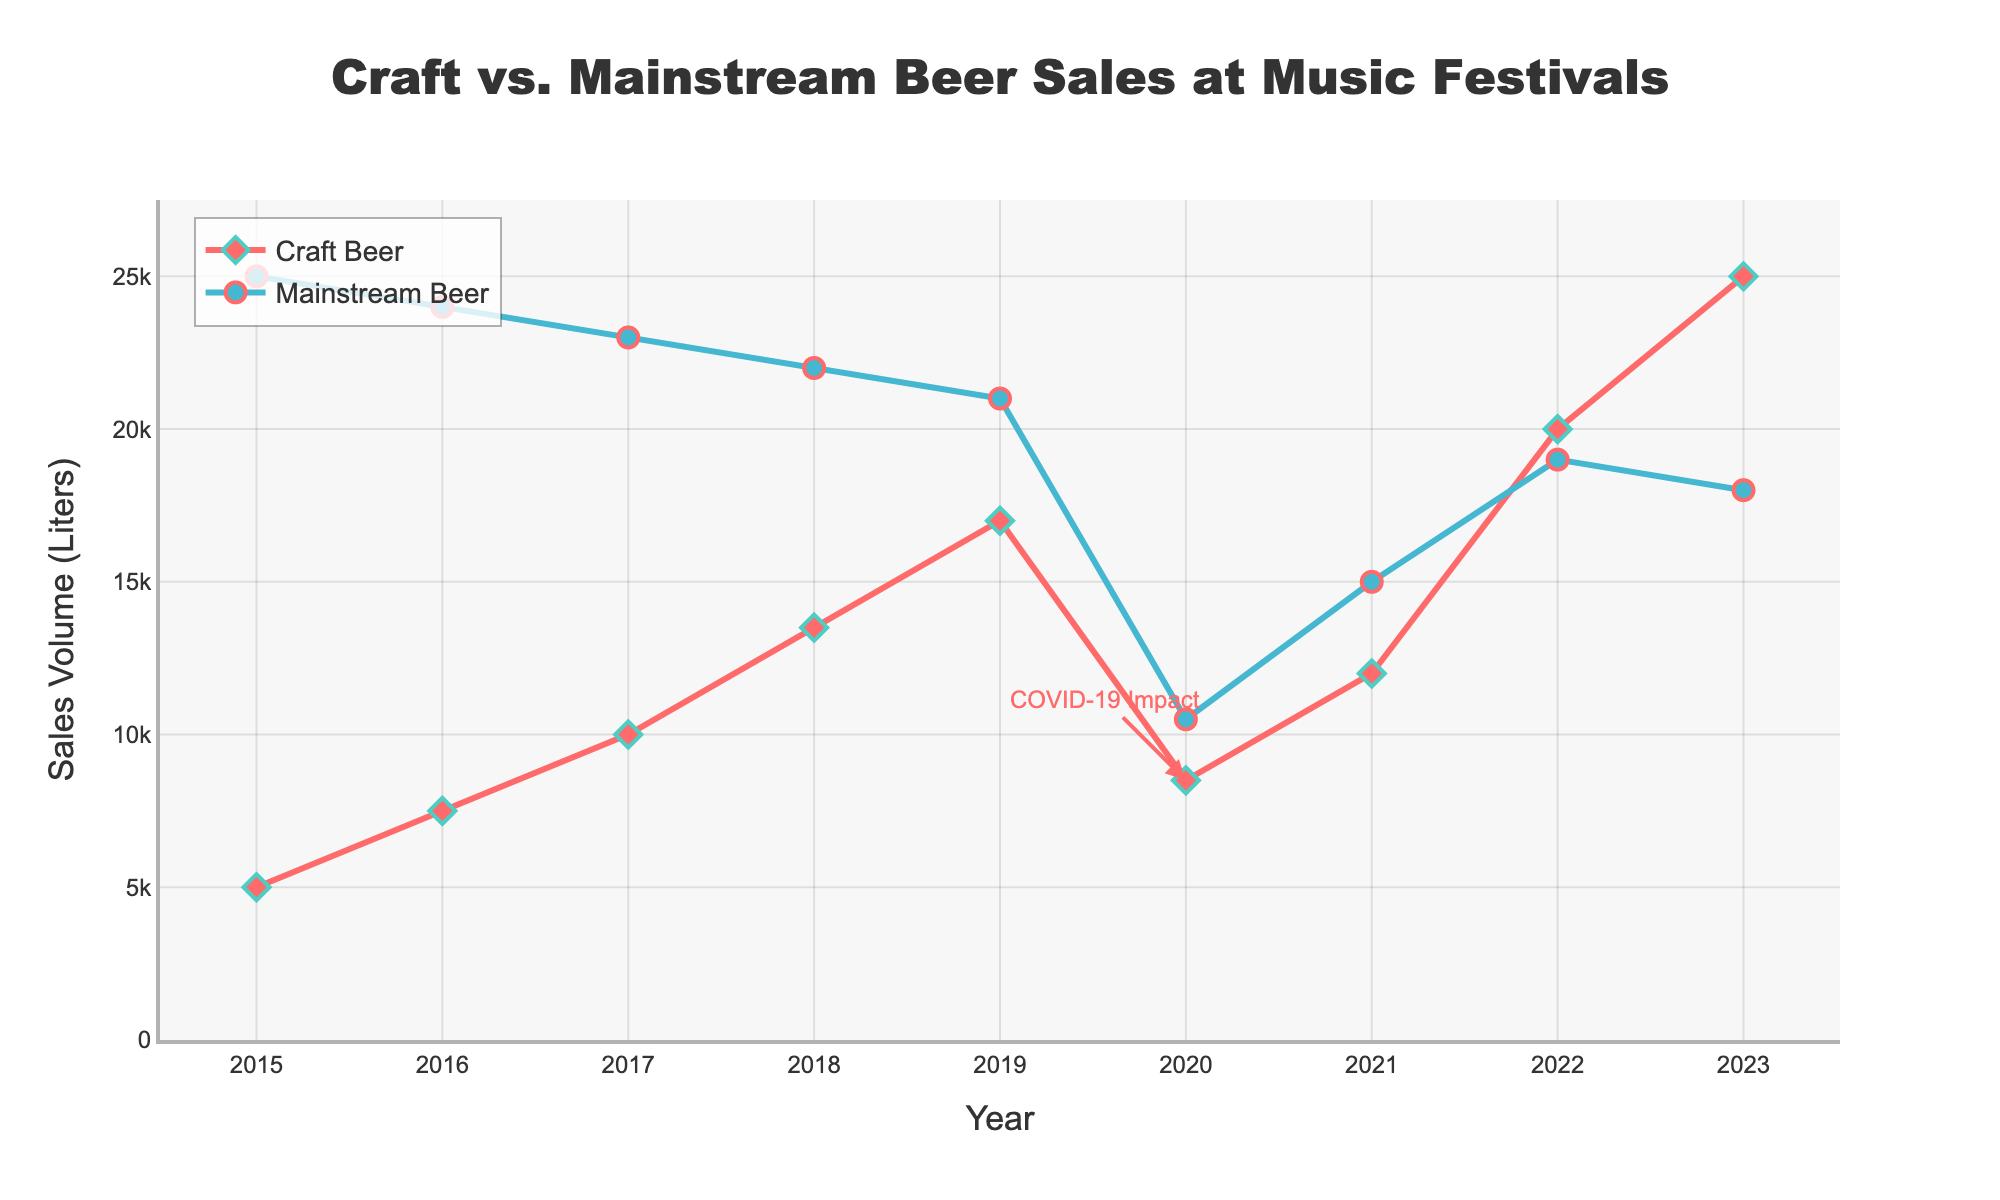What year did craft beer sales surpass mainstream beer sales? Looking at the chart, craft beer sales first surpass mainstream beer sales in 2022, where the line representing craft beer sales crosses above the line representing mainstream beer sales.
Answer: 2022 What is the overall trend in craft beer sales from 2015 to 2023? The trend shows that craft beer sales have generally increased over time, except for a noticeable dip in 2020. After 2020, the sales continue to rise again until they surpass mainstream beer sales in 2022.
Answer: Increasing How did the COVID-19 pandemic impact beer sales for both categories in 2020? There is a significant drop in sales for both craft and mainstream beers in 2020, indicating the impact of the COVID-19 pandemic. Both lines dip noticeably in that year.
Answer: Both decreased What is the difference in sales volume between craft and mainstream beer in 2023? In 2023, craft beer sales are at 25,000 liters and mainstream beer sales are at 18,000 liters. The difference is 25,000 - 18,000 = 7,000 liters.
Answer: 7,000 liters Which type of beer experienced a more significant change in sales volume between 2019 and 2020? Craft beer sales dropped from 17,000 liters in 2019 to 8,500 liters in 2020, a decrease of 8,500 liters. Mainstream beer sales dropped from 21,000 liters to 10,500 liters, a decrease of 10,500 liters. So, mainstream beer experienced a more significant change.
Answer: Mainstream beer What is the average sales volume for craft beer from 2015 to 2023? Adding the yearly sales volumes for craft beer (5000 + 7500 + 10000 + 13500 + 17000 + 8500 + 12000 + 20000 + 25000) gives a sum of 118,500 liters. There are 9 years in the data, so the average is 118,500 / 9 = 13,166.67 liters.
Answer: 13,166.67 liters Which type of beer showed a consistent decrease in sales volume from 2015 to 2020? The line representing mainstream beer sales steadily decreases each year from 2015 (25,000 liters) to 2020 (10,500 liters), indicating a consistent reduction in sales volume.
Answer: Mainstream beer What annotation is marked on the chart, and what does it refer to? The annotation marked on the chart is "COVID-19 Impact" placed around the year 2020. This indicates a significant event that caused a dip in both craft and mainstream beer sales.
Answer: COVID-19 Impact 